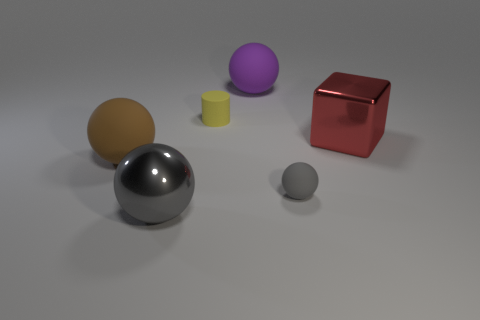Add 1 big cyan things. How many objects exist? 7 Subtract all blocks. How many objects are left? 5 Add 3 big gray blocks. How many big gray blocks exist? 3 Subtract 1 brown balls. How many objects are left? 5 Subtract all big green balls. Subtract all small gray matte balls. How many objects are left? 5 Add 3 gray balls. How many gray balls are left? 5 